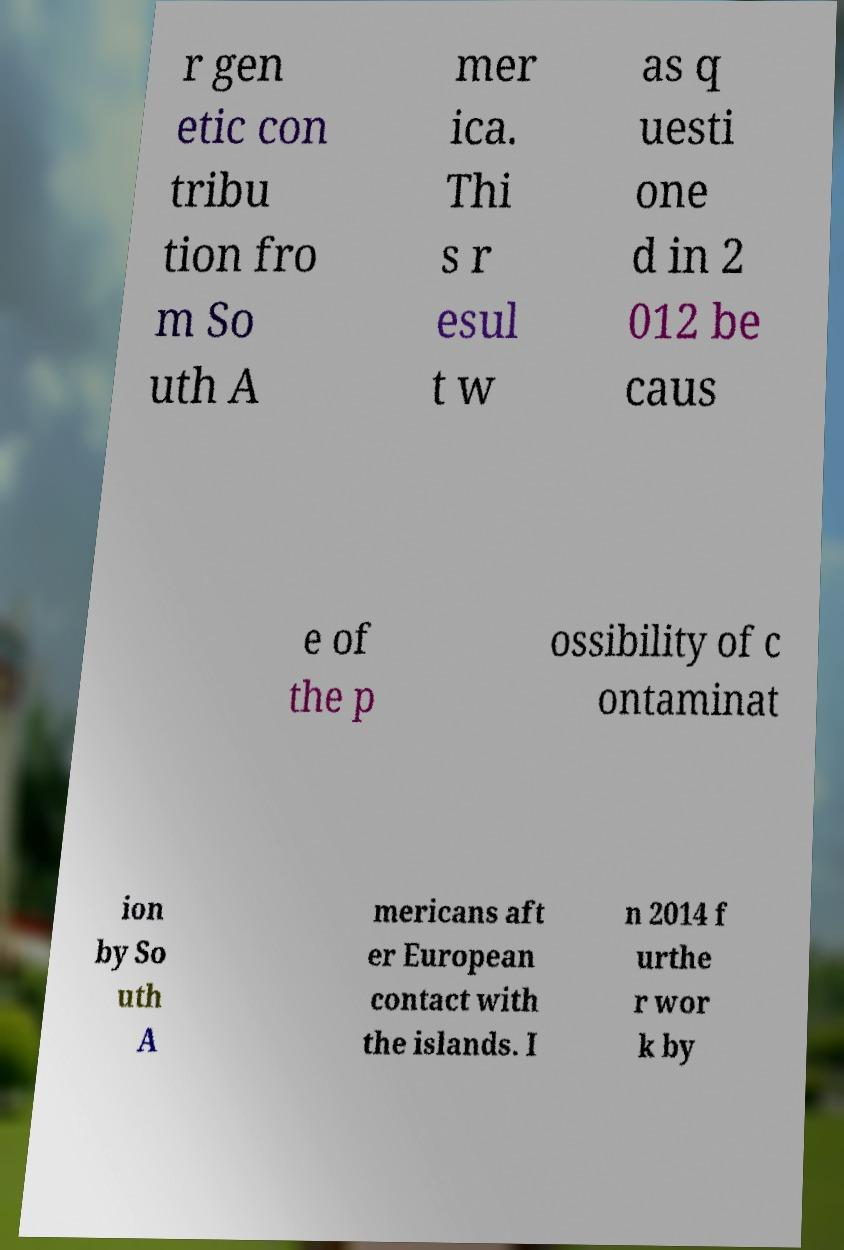For documentation purposes, I need the text within this image transcribed. Could you provide that? r gen etic con tribu tion fro m So uth A mer ica. Thi s r esul t w as q uesti one d in 2 012 be caus e of the p ossibility of c ontaminat ion by So uth A mericans aft er European contact with the islands. I n 2014 f urthe r wor k by 